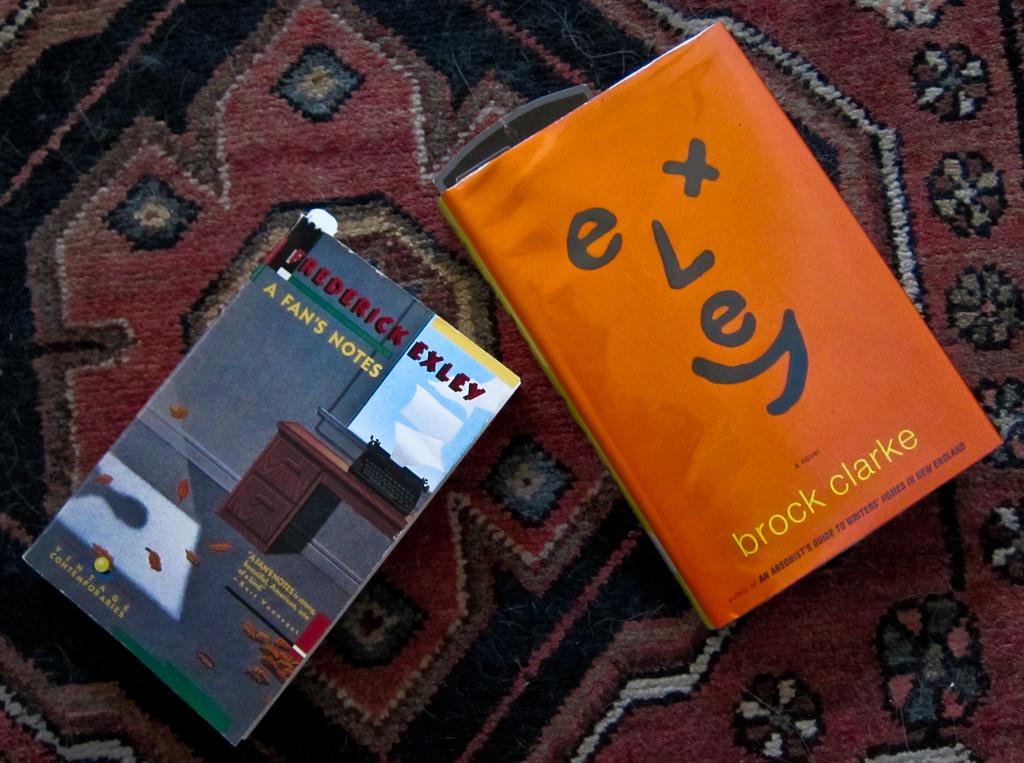Whose notes are in the book on the left?
Provide a succinct answer. A fan's. 